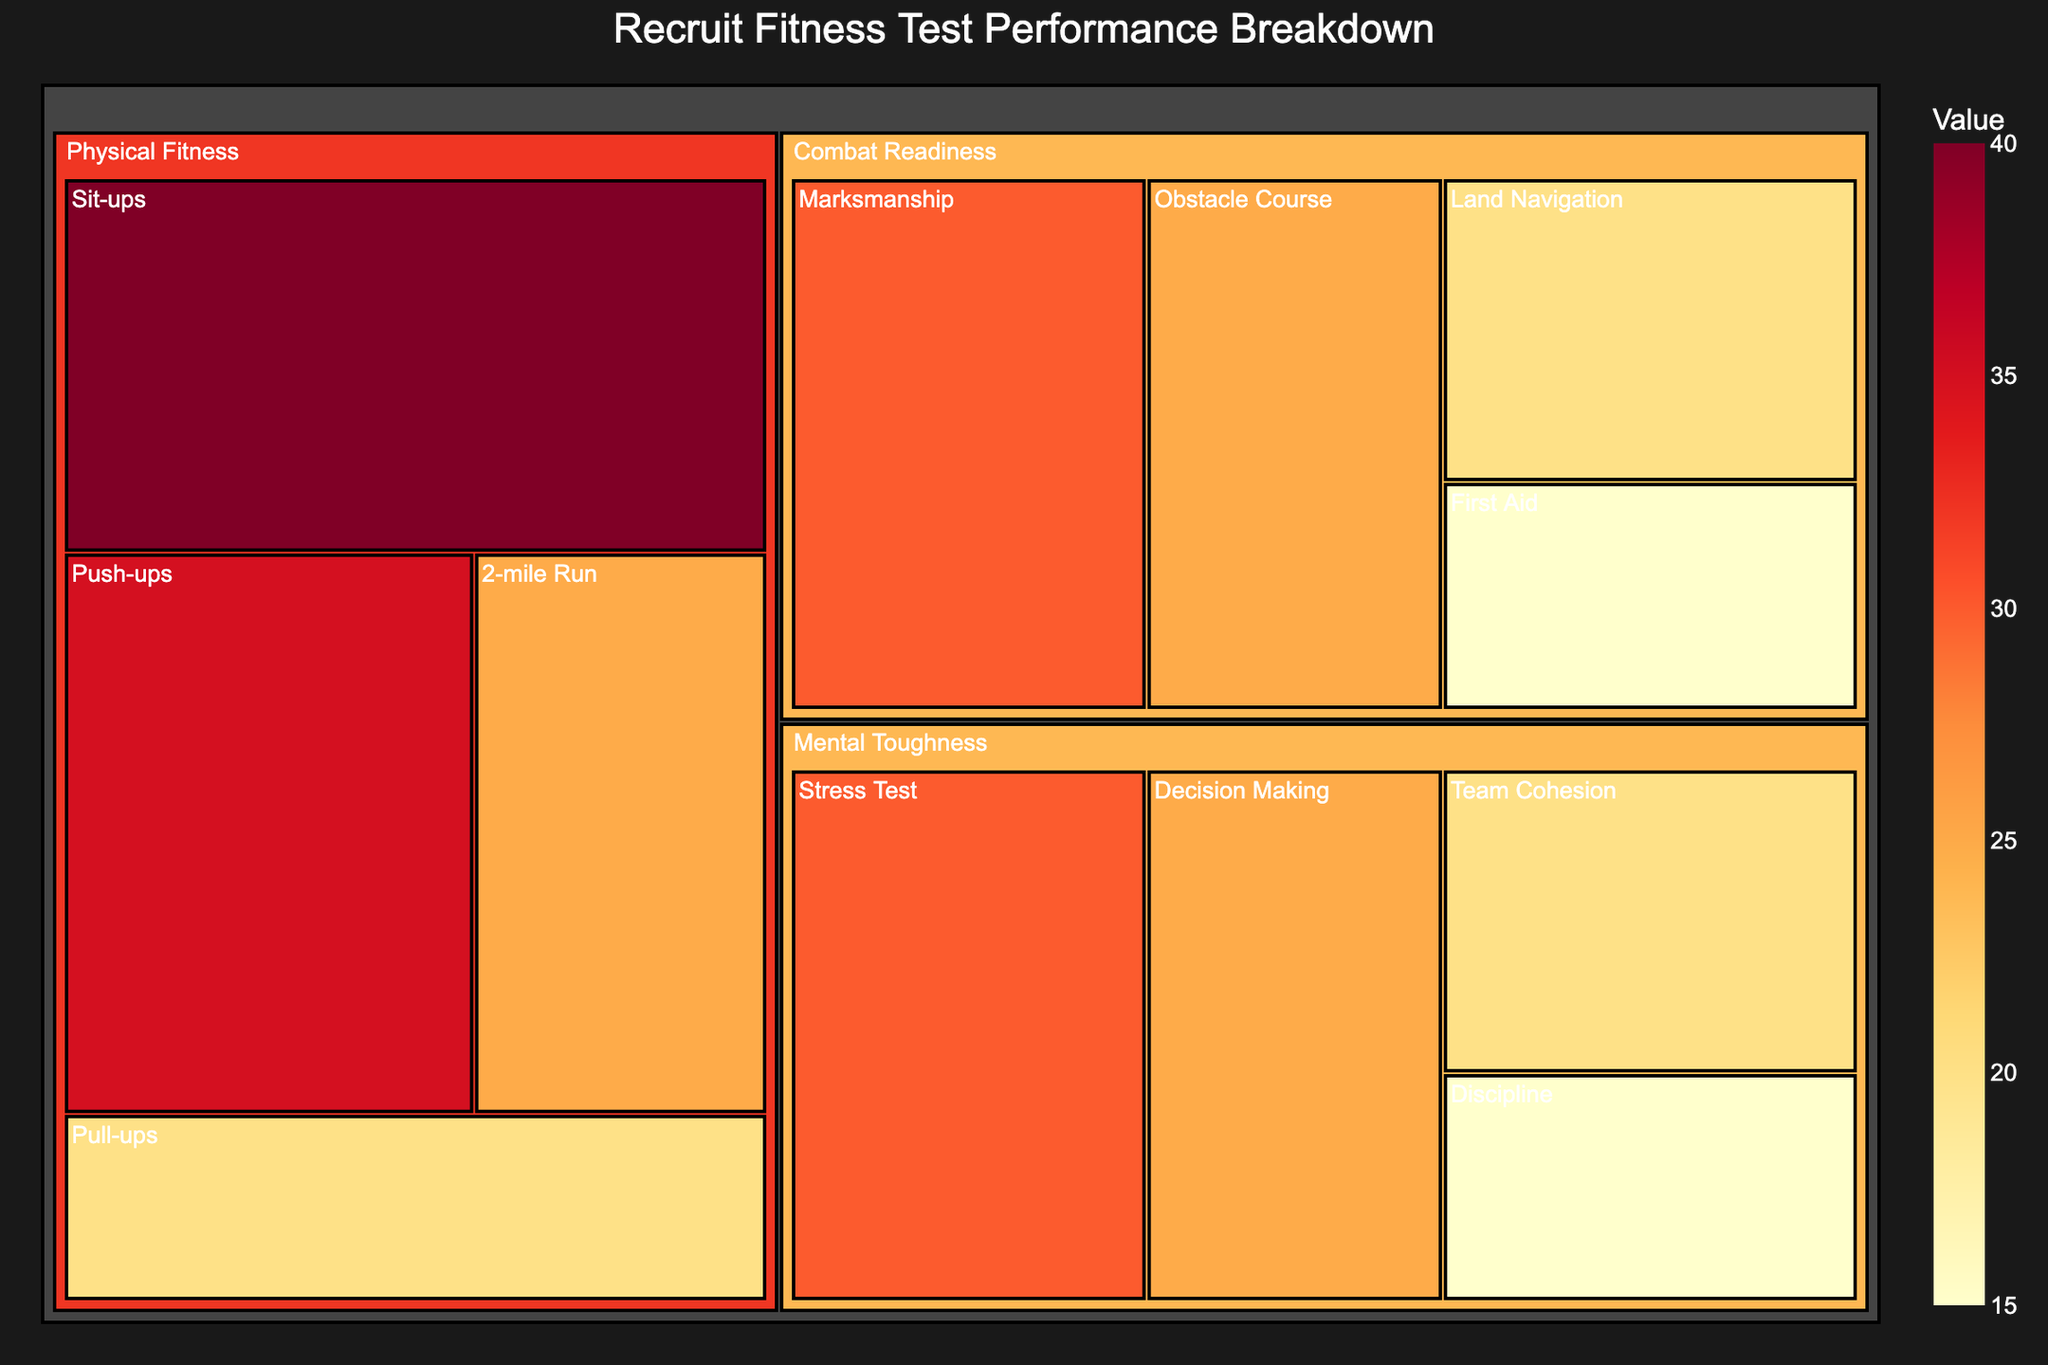What is the title of the treemap? The title of the treemap is located at the top and provides a summary of the figure
Answer: Recruit Fitness Test Performance Breakdown How many subcategories are under the Mental Toughness category? The Mental Toughness category contains four subcategories, which can be seen grouped together within its segment
Answer: Four Which subcategory has the highest value under the Physical Fitness category? To determine this, look at the values associated with each subcategory under Physical Fitness. The one with the greatest value is the highest
Answer: Sit-ups What's the total value for the Combat Readiness category? Add up the values of all subcategories under the Combat Readiness category: 30 (Marksmanship) + 25 (Obstacle Course) + 20 (Land Navigation) + 15 (First Aid) = 90
Answer: 90 Compare the values of the Stress Test and Push-ups subcategories. Which has a higher value? Look at the value of the Stress Test under Mental Toughness (30) and compare it to the value of Push-ups under Physical Fitness (35). Determine which is higher
Answer: Push-ups What is the combined value of the Decision Making and Team Cohesion subcategories? Add the value of Decision Making (25) to the value of Team Cohesion (20) from the Mental Toughness category: 25 + 20 = 45
Answer: 45 Which category has the largest total value, based on all its subcategories combined? Sum the values of subcategories for each category: Physical Fitness (120), Combat Readiness (90), and Mental Toughness (90). The category with the highest sum is the largest
Answer: Physical Fitness How does the value of Marksmanship compare to Pull-ups? Identify the value of Marksmanship (30) under Combat Readiness and compare it to the value of Pull-ups (20) under Physical Fitness. Determine the relation
Answer: Marksmanship is higher What's the average value of the subcategories under Mental Toughness? Sum the values of the four subcategories under Mental Toughness: 30 (Stress Test) + 25 (Decision Making) + 20 (Team Cohesion) + 15 (Discipline) = 90. Then divide by the number of subcategories: 90 ÷ 4 = 22.5
Answer: 22.5 